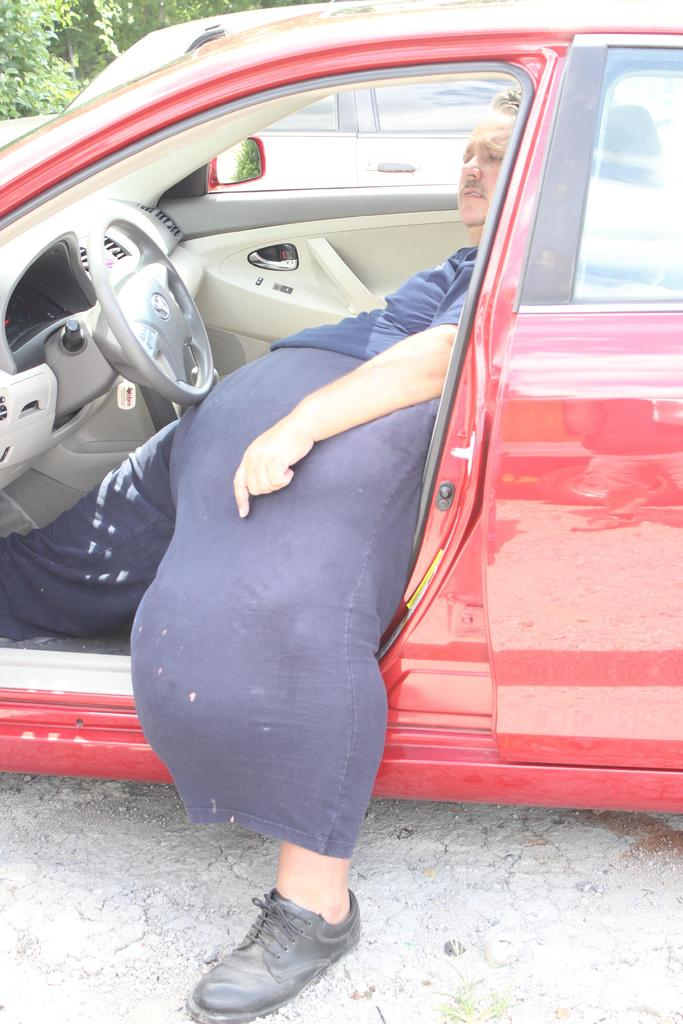What is the color of the car in which the person is sitting? The person is sitting in a red car. Can you describe any other vehicles in the image? There is another car in the image. What can be seen in the background of the image? Trees are visible in the background of the image. What scent is emanating from the yak in the image? There is no yak present in the image, so it is not possible to determine any scent. 